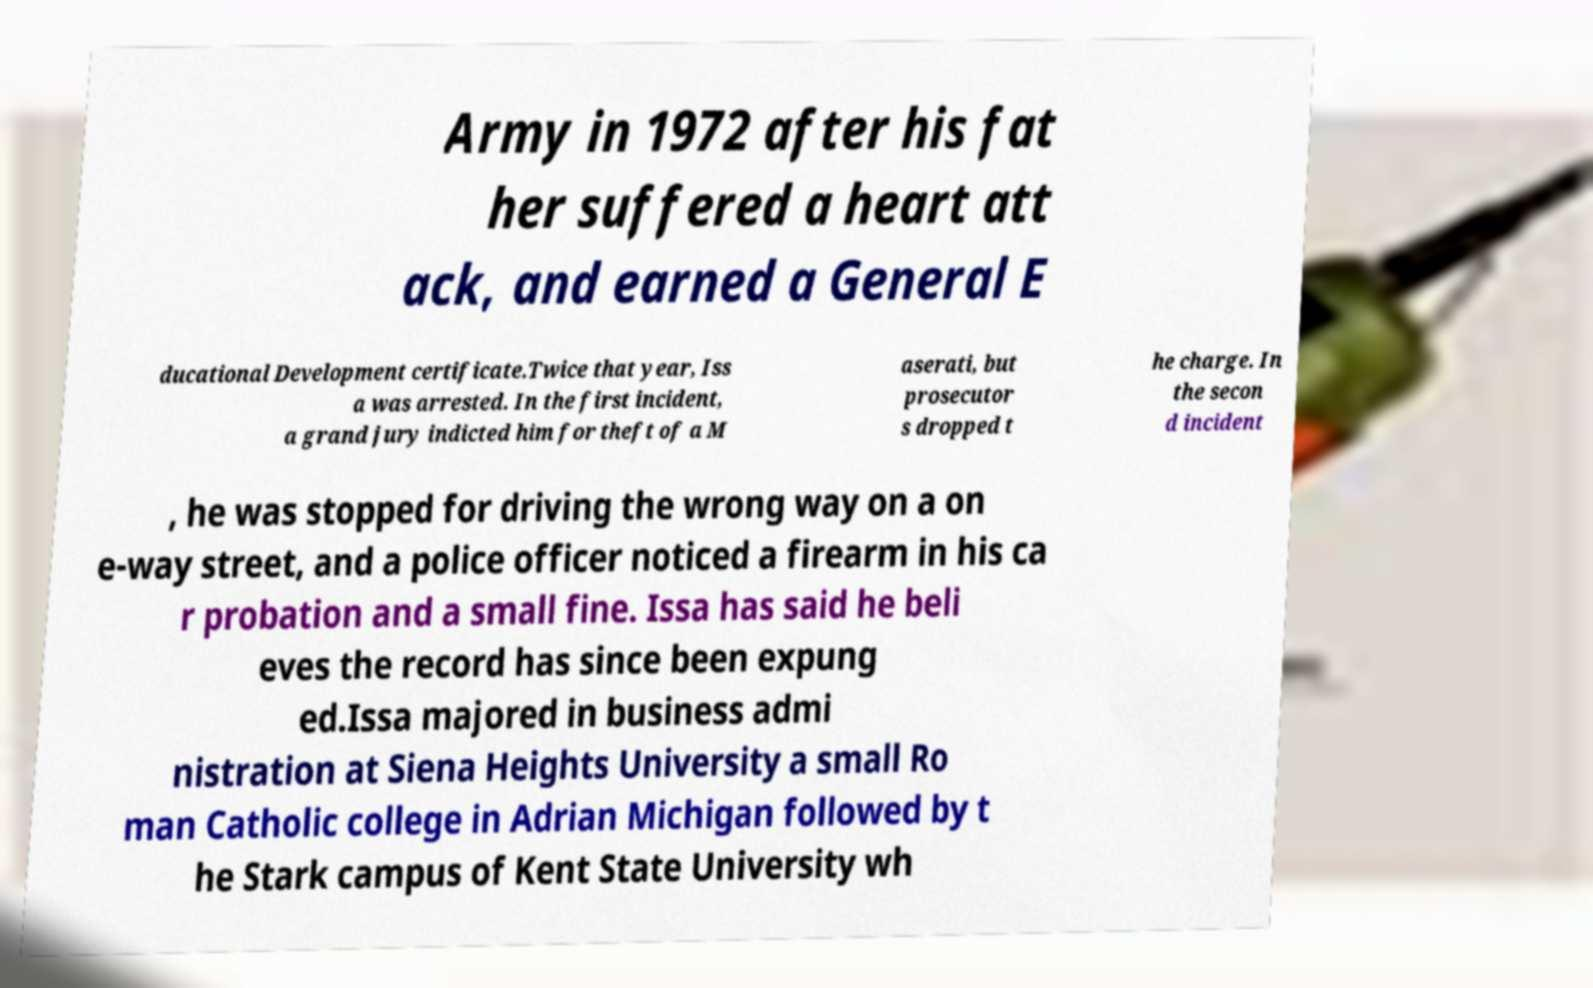Can you accurately transcribe the text from the provided image for me? Army in 1972 after his fat her suffered a heart att ack, and earned a General E ducational Development certificate.Twice that year, Iss a was arrested. In the first incident, a grand jury indicted him for theft of a M aserati, but prosecutor s dropped t he charge. In the secon d incident , he was stopped for driving the wrong way on a on e-way street, and a police officer noticed a firearm in his ca r probation and a small fine. Issa has said he beli eves the record has since been expung ed.Issa majored in business admi nistration at Siena Heights University a small Ro man Catholic college in Adrian Michigan followed by t he Stark campus of Kent State University wh 